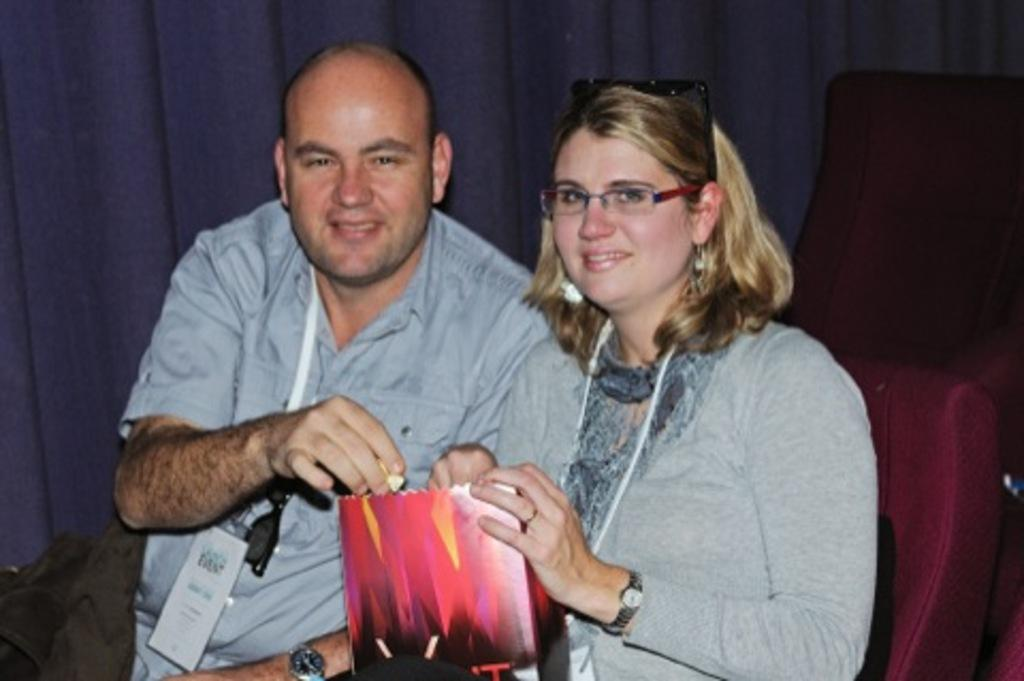How many people are in the image? There are two persons in the image. What are the persons doing in the image? The persons are sitting on chairs. What are the persons holding in the image? The persons are holding objects. What can be seen in the background of the image? There is a wall in the background of the image. Is there a volcano erupting in the background of the image? No, there is no volcano present in the image. How many legs does each person have in the image? The question about the number of legs is irrelevant, as the focus should be on the visible actions and objects in the image. 